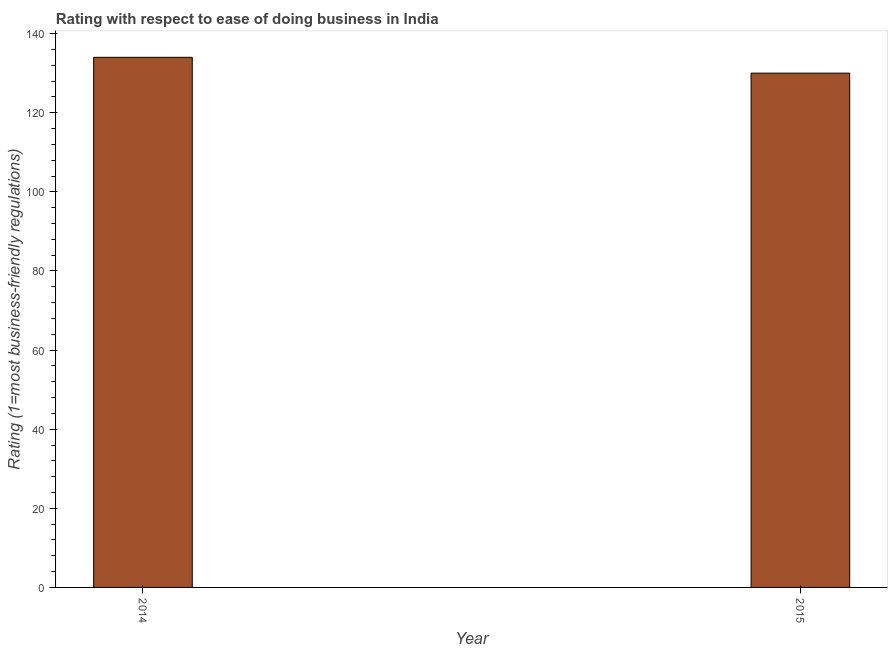Does the graph contain grids?
Your answer should be compact. No. What is the title of the graph?
Keep it short and to the point. Rating with respect to ease of doing business in India. What is the label or title of the X-axis?
Ensure brevity in your answer.  Year. What is the label or title of the Y-axis?
Your answer should be very brief. Rating (1=most business-friendly regulations). What is the ease of doing business index in 2015?
Provide a short and direct response. 130. Across all years, what is the maximum ease of doing business index?
Offer a terse response. 134. Across all years, what is the minimum ease of doing business index?
Your answer should be very brief. 130. In which year was the ease of doing business index maximum?
Keep it short and to the point. 2014. In which year was the ease of doing business index minimum?
Offer a very short reply. 2015. What is the sum of the ease of doing business index?
Offer a terse response. 264. What is the difference between the ease of doing business index in 2014 and 2015?
Your answer should be very brief. 4. What is the average ease of doing business index per year?
Provide a succinct answer. 132. What is the median ease of doing business index?
Your answer should be very brief. 132. In how many years, is the ease of doing business index greater than 20 ?
Provide a succinct answer. 2. What is the ratio of the ease of doing business index in 2014 to that in 2015?
Give a very brief answer. 1.03. Is the ease of doing business index in 2014 less than that in 2015?
Ensure brevity in your answer.  No. In how many years, is the ease of doing business index greater than the average ease of doing business index taken over all years?
Ensure brevity in your answer.  1. How many bars are there?
Provide a short and direct response. 2. Are all the bars in the graph horizontal?
Make the answer very short. No. Are the values on the major ticks of Y-axis written in scientific E-notation?
Make the answer very short. No. What is the Rating (1=most business-friendly regulations) in 2014?
Provide a short and direct response. 134. What is the Rating (1=most business-friendly regulations) of 2015?
Make the answer very short. 130. What is the ratio of the Rating (1=most business-friendly regulations) in 2014 to that in 2015?
Your answer should be very brief. 1.03. 